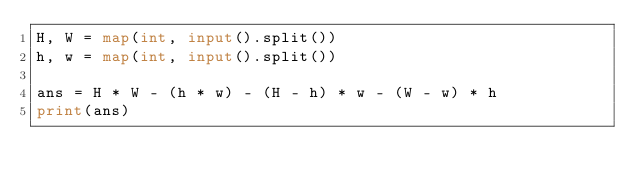Convert code to text. <code><loc_0><loc_0><loc_500><loc_500><_Python_>H, W = map(int, input().split())
h, w = map(int, input().split())

ans = H * W - (h * w) - (H - h) * w - (W - w) * h
print(ans)</code> 